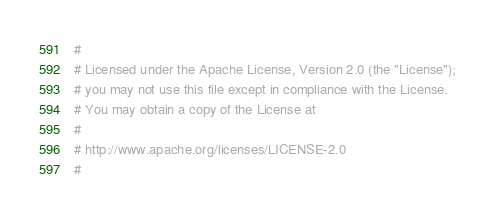Convert code to text. <code><loc_0><loc_0><loc_500><loc_500><_YAML_>#
# Licensed under the Apache License, Version 2.0 (the "License");
# you may not use this file except in compliance with the License.
# You may obtain a copy of the License at
#
# http://www.apache.org/licenses/LICENSE-2.0
#</code> 